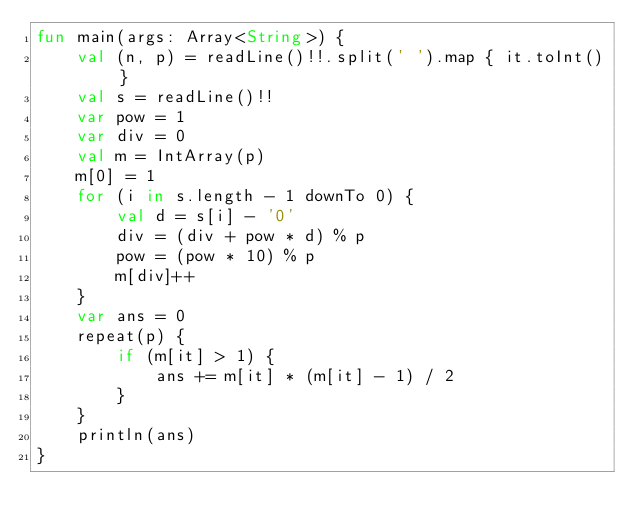Convert code to text. <code><loc_0><loc_0><loc_500><loc_500><_Kotlin_>fun main(args: Array<String>) {
    val (n, p) = readLine()!!.split(' ').map { it.toInt() }
    val s = readLine()!!
    var pow = 1
    var div = 0
    val m = IntArray(p)
    m[0] = 1
    for (i in s.length - 1 downTo 0) {
        val d = s[i] - '0'
        div = (div + pow * d) % p
        pow = (pow * 10) % p
        m[div]++
    }
    var ans = 0
    repeat(p) {
        if (m[it] > 1) {
            ans += m[it] * (m[it] - 1) / 2
        }
    }
    println(ans)
}
</code> 